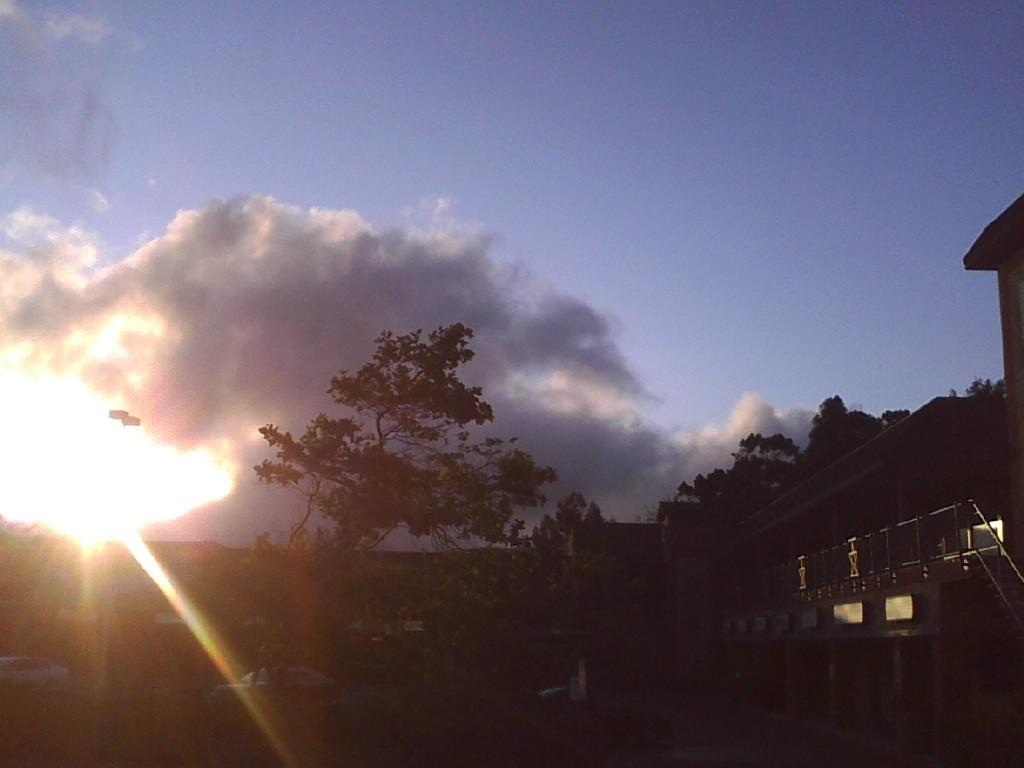What type of natural elements can be seen in the image? There are trees in the image. What type of man-made structures are present in the image? There are buildings in the image. What is the source of light in the sky? There is sunlight in the sky. What is the weather condition in the image? The sky is cloudy. What type of ornament is hanging from the tree in the image? There is no ornament hanging from the tree in the image; only trees and buildings are present. How does the earth appear in the image? The image does not show the earth as a whole; it only shows a portion of the landscape with trees and buildings. 